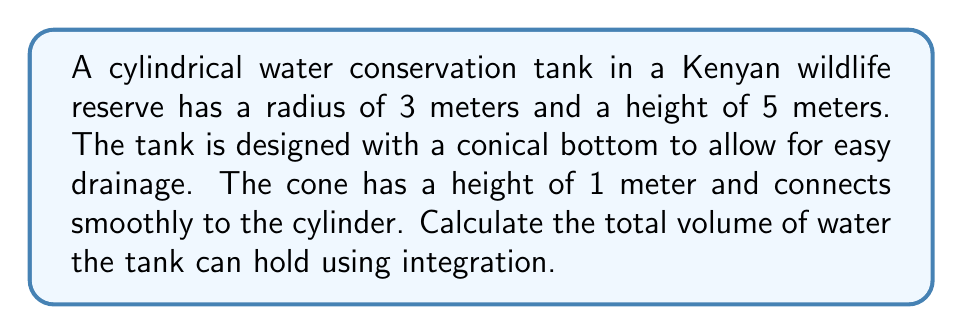Can you solve this math problem? To solve this problem, we need to use the method of integration to find the volume of both the cylindrical and conical parts of the tank.

Step 1: Calculate the volume of the cylindrical part
The volume of a cylinder is given by $V = \pi r^2 h$
$V_{cylinder} = \pi (3\text{ m})^2 (4\text{ m}) = 36\pi\text{ m}^3$

Step 2: Set up the integral for the conical part
For the conical part, we'll use the method of disks. The radius of each disk varies with height.
The equation of the line forming the side of the cone is:
$r = 3 - 3h$ (where $h$ is measured from the bottom of the cone)

The volume of the cone is given by:
$$V_{cone} = \int_0^1 \pi r^2 dh = \pi \int_0^1 (3-3h)^2 dh$$

Step 3: Solve the integral
$$\begin{align}
V_{cone} &= \pi \int_0^1 (9-18h+9h^2) dh \\
&= \pi \left[9h - 9h^2 + 3h^3\right]_0^1 \\
&= \pi (9 - 9 + 3) \\
&= 3\pi\text{ m}^3
\end{align}$$

Step 4: Calculate the total volume
$V_{total} = V_{cylinder} + V_{cone} = 36\pi\text{ m}^3 + 3\pi\text{ m}^3 = 39\pi\text{ m}^3$
Answer: $39\pi\text{ m}^3$ 